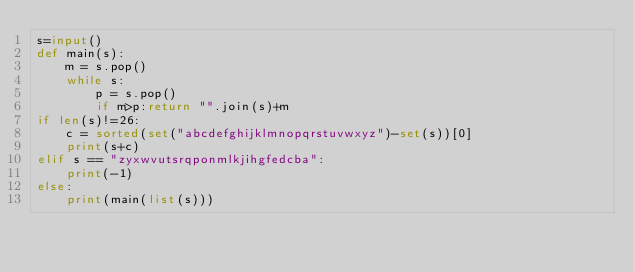<code> <loc_0><loc_0><loc_500><loc_500><_Python_>s=input()
def main(s):
    m = s.pop()
    while s:
        p = s.pop()
        if m>p:return "".join(s)+m
if len(s)!=26:
    c = sorted(set("abcdefghijklmnopqrstuvwxyz")-set(s))[0]
    print(s+c)
elif s == "zyxwvutsrqponmlkjihgfedcba":
    print(-1)
else:
    print(main(list(s)))</code> 